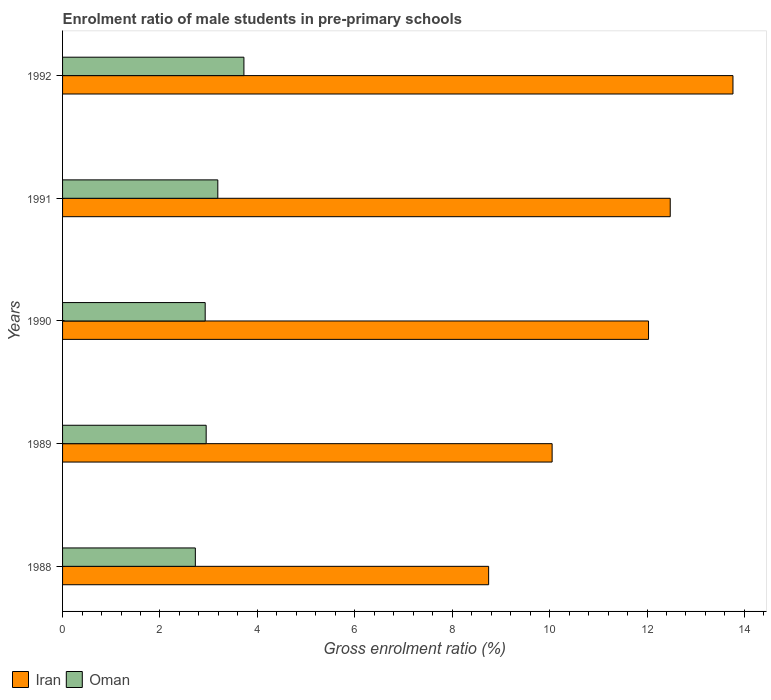How many different coloured bars are there?
Provide a succinct answer. 2. How many groups of bars are there?
Provide a short and direct response. 5. Are the number of bars on each tick of the Y-axis equal?
Provide a short and direct response. Yes. How many bars are there on the 5th tick from the top?
Offer a terse response. 2. What is the label of the 4th group of bars from the top?
Your answer should be compact. 1989. In how many cases, is the number of bars for a given year not equal to the number of legend labels?
Keep it short and to the point. 0. What is the enrolment ratio of male students in pre-primary schools in Iran in 1991?
Your response must be concise. 12.48. Across all years, what is the maximum enrolment ratio of male students in pre-primary schools in Iran?
Your answer should be very brief. 13.76. Across all years, what is the minimum enrolment ratio of male students in pre-primary schools in Iran?
Ensure brevity in your answer.  8.75. What is the total enrolment ratio of male students in pre-primary schools in Oman in the graph?
Provide a succinct answer. 15.51. What is the difference between the enrolment ratio of male students in pre-primary schools in Oman in 1989 and that in 1990?
Make the answer very short. 0.02. What is the difference between the enrolment ratio of male students in pre-primary schools in Oman in 1990 and the enrolment ratio of male students in pre-primary schools in Iran in 1991?
Offer a very short reply. -9.55. What is the average enrolment ratio of male students in pre-primary schools in Iran per year?
Make the answer very short. 11.41. In the year 1989, what is the difference between the enrolment ratio of male students in pre-primary schools in Iran and enrolment ratio of male students in pre-primary schools in Oman?
Keep it short and to the point. 7.1. What is the ratio of the enrolment ratio of male students in pre-primary schools in Iran in 1988 to that in 1992?
Make the answer very short. 0.64. Is the enrolment ratio of male students in pre-primary schools in Iran in 1989 less than that in 1991?
Your response must be concise. Yes. Is the difference between the enrolment ratio of male students in pre-primary schools in Iran in 1988 and 1989 greater than the difference between the enrolment ratio of male students in pre-primary schools in Oman in 1988 and 1989?
Offer a very short reply. No. What is the difference between the highest and the second highest enrolment ratio of male students in pre-primary schools in Iran?
Your answer should be compact. 1.29. What is the difference between the highest and the lowest enrolment ratio of male students in pre-primary schools in Iran?
Your answer should be very brief. 5.02. In how many years, is the enrolment ratio of male students in pre-primary schools in Iran greater than the average enrolment ratio of male students in pre-primary schools in Iran taken over all years?
Your answer should be very brief. 3. Is the sum of the enrolment ratio of male students in pre-primary schools in Iran in 1989 and 1990 greater than the maximum enrolment ratio of male students in pre-primary schools in Oman across all years?
Make the answer very short. Yes. What does the 1st bar from the top in 1992 represents?
Your answer should be very brief. Oman. What does the 1st bar from the bottom in 1992 represents?
Make the answer very short. Iran. How many bars are there?
Provide a short and direct response. 10. Are all the bars in the graph horizontal?
Make the answer very short. Yes. How many years are there in the graph?
Your answer should be very brief. 5. What is the difference between two consecutive major ticks on the X-axis?
Your answer should be compact. 2. Are the values on the major ticks of X-axis written in scientific E-notation?
Offer a terse response. No. Where does the legend appear in the graph?
Offer a very short reply. Bottom left. How are the legend labels stacked?
Give a very brief answer. Horizontal. What is the title of the graph?
Offer a terse response. Enrolment ratio of male students in pre-primary schools. Does "Croatia" appear as one of the legend labels in the graph?
Offer a terse response. No. What is the Gross enrolment ratio (%) of Iran in 1988?
Make the answer very short. 8.75. What is the Gross enrolment ratio (%) in Oman in 1988?
Your answer should be compact. 2.73. What is the Gross enrolment ratio (%) in Iran in 1989?
Provide a succinct answer. 10.05. What is the Gross enrolment ratio (%) in Oman in 1989?
Your answer should be very brief. 2.95. What is the Gross enrolment ratio (%) of Iran in 1990?
Provide a succinct answer. 12.03. What is the Gross enrolment ratio (%) in Oman in 1990?
Provide a succinct answer. 2.93. What is the Gross enrolment ratio (%) in Iran in 1991?
Give a very brief answer. 12.48. What is the Gross enrolment ratio (%) of Oman in 1991?
Offer a very short reply. 3.19. What is the Gross enrolment ratio (%) in Iran in 1992?
Ensure brevity in your answer.  13.76. What is the Gross enrolment ratio (%) of Oman in 1992?
Make the answer very short. 3.72. Across all years, what is the maximum Gross enrolment ratio (%) in Iran?
Provide a succinct answer. 13.76. Across all years, what is the maximum Gross enrolment ratio (%) of Oman?
Provide a succinct answer. 3.72. Across all years, what is the minimum Gross enrolment ratio (%) of Iran?
Your response must be concise. 8.75. Across all years, what is the minimum Gross enrolment ratio (%) of Oman?
Provide a succinct answer. 2.73. What is the total Gross enrolment ratio (%) in Iran in the graph?
Provide a short and direct response. 57.07. What is the total Gross enrolment ratio (%) of Oman in the graph?
Ensure brevity in your answer.  15.51. What is the difference between the Gross enrolment ratio (%) in Iran in 1988 and that in 1989?
Provide a short and direct response. -1.3. What is the difference between the Gross enrolment ratio (%) of Oman in 1988 and that in 1989?
Make the answer very short. -0.22. What is the difference between the Gross enrolment ratio (%) of Iran in 1988 and that in 1990?
Your answer should be very brief. -3.28. What is the difference between the Gross enrolment ratio (%) of Oman in 1988 and that in 1990?
Make the answer very short. -0.2. What is the difference between the Gross enrolment ratio (%) in Iran in 1988 and that in 1991?
Keep it short and to the point. -3.73. What is the difference between the Gross enrolment ratio (%) of Oman in 1988 and that in 1991?
Your response must be concise. -0.46. What is the difference between the Gross enrolment ratio (%) of Iran in 1988 and that in 1992?
Offer a very short reply. -5.02. What is the difference between the Gross enrolment ratio (%) of Oman in 1988 and that in 1992?
Your answer should be very brief. -1. What is the difference between the Gross enrolment ratio (%) of Iran in 1989 and that in 1990?
Give a very brief answer. -1.98. What is the difference between the Gross enrolment ratio (%) of Oman in 1989 and that in 1990?
Your response must be concise. 0.02. What is the difference between the Gross enrolment ratio (%) of Iran in 1989 and that in 1991?
Keep it short and to the point. -2.43. What is the difference between the Gross enrolment ratio (%) of Oman in 1989 and that in 1991?
Offer a very short reply. -0.24. What is the difference between the Gross enrolment ratio (%) of Iran in 1989 and that in 1992?
Your response must be concise. -3.71. What is the difference between the Gross enrolment ratio (%) in Oman in 1989 and that in 1992?
Provide a succinct answer. -0.77. What is the difference between the Gross enrolment ratio (%) in Iran in 1990 and that in 1991?
Provide a succinct answer. -0.45. What is the difference between the Gross enrolment ratio (%) of Oman in 1990 and that in 1991?
Give a very brief answer. -0.26. What is the difference between the Gross enrolment ratio (%) in Iran in 1990 and that in 1992?
Provide a short and direct response. -1.73. What is the difference between the Gross enrolment ratio (%) of Oman in 1990 and that in 1992?
Make the answer very short. -0.8. What is the difference between the Gross enrolment ratio (%) of Iran in 1991 and that in 1992?
Give a very brief answer. -1.29. What is the difference between the Gross enrolment ratio (%) of Oman in 1991 and that in 1992?
Make the answer very short. -0.54. What is the difference between the Gross enrolment ratio (%) of Iran in 1988 and the Gross enrolment ratio (%) of Oman in 1989?
Provide a short and direct response. 5.8. What is the difference between the Gross enrolment ratio (%) of Iran in 1988 and the Gross enrolment ratio (%) of Oman in 1990?
Provide a short and direct response. 5.82. What is the difference between the Gross enrolment ratio (%) of Iran in 1988 and the Gross enrolment ratio (%) of Oman in 1991?
Make the answer very short. 5.56. What is the difference between the Gross enrolment ratio (%) of Iran in 1988 and the Gross enrolment ratio (%) of Oman in 1992?
Ensure brevity in your answer.  5.02. What is the difference between the Gross enrolment ratio (%) of Iran in 1989 and the Gross enrolment ratio (%) of Oman in 1990?
Your answer should be very brief. 7.12. What is the difference between the Gross enrolment ratio (%) in Iran in 1989 and the Gross enrolment ratio (%) in Oman in 1991?
Provide a succinct answer. 6.86. What is the difference between the Gross enrolment ratio (%) of Iran in 1989 and the Gross enrolment ratio (%) of Oman in 1992?
Your answer should be very brief. 6.33. What is the difference between the Gross enrolment ratio (%) of Iran in 1990 and the Gross enrolment ratio (%) of Oman in 1991?
Give a very brief answer. 8.84. What is the difference between the Gross enrolment ratio (%) in Iran in 1990 and the Gross enrolment ratio (%) in Oman in 1992?
Offer a very short reply. 8.31. What is the difference between the Gross enrolment ratio (%) of Iran in 1991 and the Gross enrolment ratio (%) of Oman in 1992?
Offer a very short reply. 8.75. What is the average Gross enrolment ratio (%) in Iran per year?
Ensure brevity in your answer.  11.41. What is the average Gross enrolment ratio (%) in Oman per year?
Make the answer very short. 3.1. In the year 1988, what is the difference between the Gross enrolment ratio (%) of Iran and Gross enrolment ratio (%) of Oman?
Offer a terse response. 6.02. In the year 1989, what is the difference between the Gross enrolment ratio (%) in Iran and Gross enrolment ratio (%) in Oman?
Ensure brevity in your answer.  7.1. In the year 1990, what is the difference between the Gross enrolment ratio (%) in Iran and Gross enrolment ratio (%) in Oman?
Make the answer very short. 9.1. In the year 1991, what is the difference between the Gross enrolment ratio (%) in Iran and Gross enrolment ratio (%) in Oman?
Your answer should be very brief. 9.29. In the year 1992, what is the difference between the Gross enrolment ratio (%) in Iran and Gross enrolment ratio (%) in Oman?
Make the answer very short. 10.04. What is the ratio of the Gross enrolment ratio (%) in Iran in 1988 to that in 1989?
Provide a short and direct response. 0.87. What is the ratio of the Gross enrolment ratio (%) of Oman in 1988 to that in 1989?
Offer a very short reply. 0.92. What is the ratio of the Gross enrolment ratio (%) in Iran in 1988 to that in 1990?
Offer a very short reply. 0.73. What is the ratio of the Gross enrolment ratio (%) in Iran in 1988 to that in 1991?
Your answer should be very brief. 0.7. What is the ratio of the Gross enrolment ratio (%) in Oman in 1988 to that in 1991?
Make the answer very short. 0.86. What is the ratio of the Gross enrolment ratio (%) of Iran in 1988 to that in 1992?
Your answer should be very brief. 0.64. What is the ratio of the Gross enrolment ratio (%) of Oman in 1988 to that in 1992?
Your answer should be very brief. 0.73. What is the ratio of the Gross enrolment ratio (%) of Iran in 1989 to that in 1990?
Provide a succinct answer. 0.84. What is the ratio of the Gross enrolment ratio (%) of Oman in 1989 to that in 1990?
Keep it short and to the point. 1.01. What is the ratio of the Gross enrolment ratio (%) of Iran in 1989 to that in 1991?
Make the answer very short. 0.81. What is the ratio of the Gross enrolment ratio (%) in Oman in 1989 to that in 1991?
Make the answer very short. 0.93. What is the ratio of the Gross enrolment ratio (%) in Iran in 1989 to that in 1992?
Your response must be concise. 0.73. What is the ratio of the Gross enrolment ratio (%) of Oman in 1989 to that in 1992?
Give a very brief answer. 0.79. What is the ratio of the Gross enrolment ratio (%) of Iran in 1990 to that in 1991?
Offer a very short reply. 0.96. What is the ratio of the Gross enrolment ratio (%) in Oman in 1990 to that in 1991?
Offer a terse response. 0.92. What is the ratio of the Gross enrolment ratio (%) in Iran in 1990 to that in 1992?
Ensure brevity in your answer.  0.87. What is the ratio of the Gross enrolment ratio (%) in Oman in 1990 to that in 1992?
Provide a short and direct response. 0.79. What is the ratio of the Gross enrolment ratio (%) in Iran in 1991 to that in 1992?
Your answer should be very brief. 0.91. What is the ratio of the Gross enrolment ratio (%) of Oman in 1991 to that in 1992?
Give a very brief answer. 0.86. What is the difference between the highest and the second highest Gross enrolment ratio (%) in Iran?
Offer a very short reply. 1.29. What is the difference between the highest and the second highest Gross enrolment ratio (%) in Oman?
Provide a short and direct response. 0.54. What is the difference between the highest and the lowest Gross enrolment ratio (%) in Iran?
Your response must be concise. 5.02. What is the difference between the highest and the lowest Gross enrolment ratio (%) of Oman?
Your answer should be very brief. 1. 